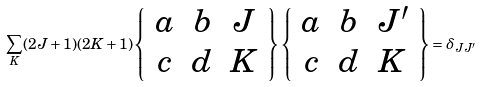Convert formula to latex. <formula><loc_0><loc_0><loc_500><loc_500>\sum _ { K } ( 2 J + 1 ) ( 2 K + 1 ) \left \{ \begin{array} { c c c } a & b & J \\ c & d & K \\ \end{array} \right \} \left \{ \begin{array} { c c c } a & b & J ^ { \prime } \\ c & d & K \\ \end{array} \right \} = \delta _ { J J ^ { \prime } }</formula> 